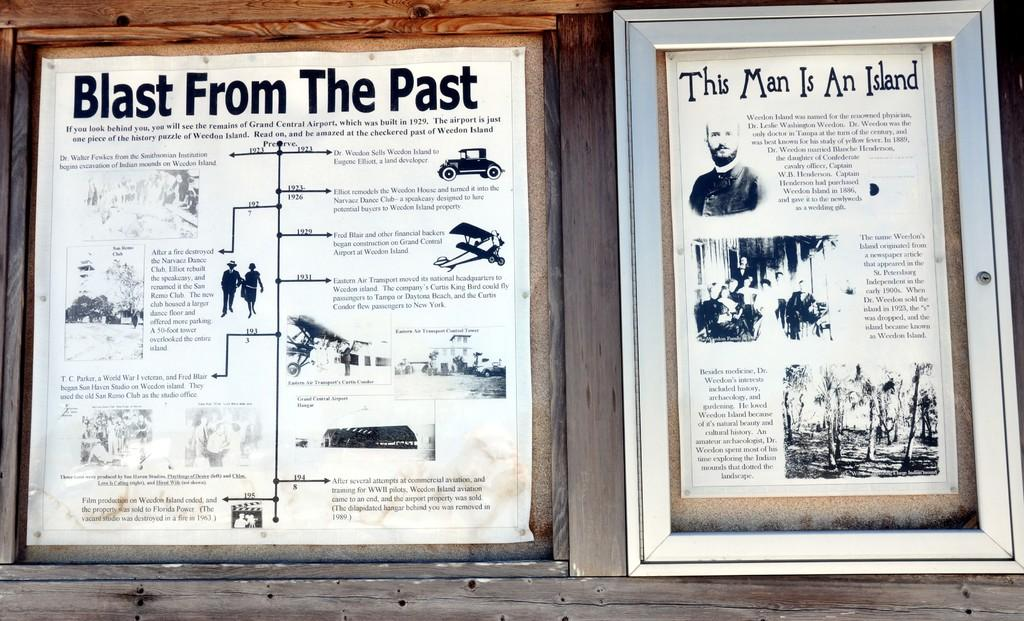<image>
Provide a brief description of the given image. Two posters in black and white, one of which has the words This Man is an Island on the top. 